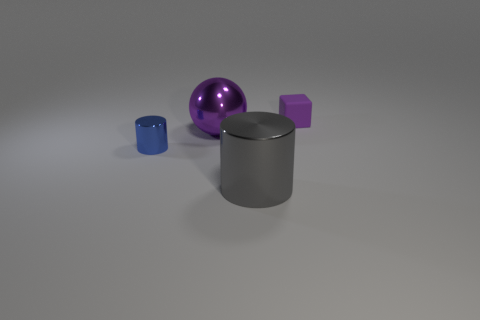There is a small object left of the tiny purple rubber thing; is it the same shape as the big metal object in front of the big purple ball?
Keep it short and to the point. Yes. What number of objects are both on the right side of the large purple shiny object and on the left side of the rubber block?
Keep it short and to the point. 1. Are there any other tiny cubes that have the same color as the small rubber cube?
Make the answer very short. No. What is the shape of the blue object that is the same size as the purple matte thing?
Offer a terse response. Cylinder. There is a small blue cylinder; are there any objects behind it?
Your response must be concise. Yes. Are the purple object in front of the block and the small object that is in front of the tiny purple thing made of the same material?
Give a very brief answer. Yes. How many metal objects have the same size as the rubber object?
Your response must be concise. 1. What shape is the rubber thing that is the same color as the big metallic ball?
Your answer should be very brief. Cube. There is a purple thing on the left side of the gray metallic cylinder; what is its material?
Your answer should be compact. Metal. What number of tiny metal things have the same shape as the big purple thing?
Keep it short and to the point. 0. 